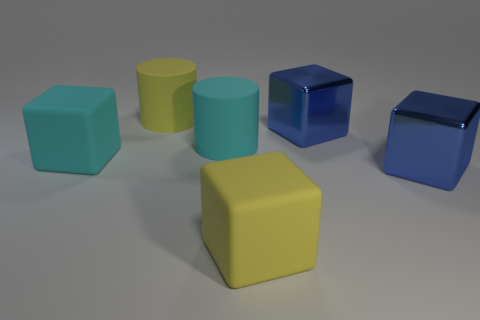Subtract all big cyan matte cubes. How many cubes are left? 3 Add 3 cylinders. How many objects exist? 9 Subtract all purple cylinders. How many blue blocks are left? 2 Subtract all blue cubes. How many cubes are left? 2 Subtract 3 cubes. How many cubes are left? 1 Subtract all cyan cubes. Subtract all blue cylinders. How many cubes are left? 3 Subtract all large cyan blocks. Subtract all large blue objects. How many objects are left? 3 Add 2 big blue things. How many big blue things are left? 4 Add 1 big cyan blocks. How many big cyan blocks exist? 2 Subtract 0 brown spheres. How many objects are left? 6 